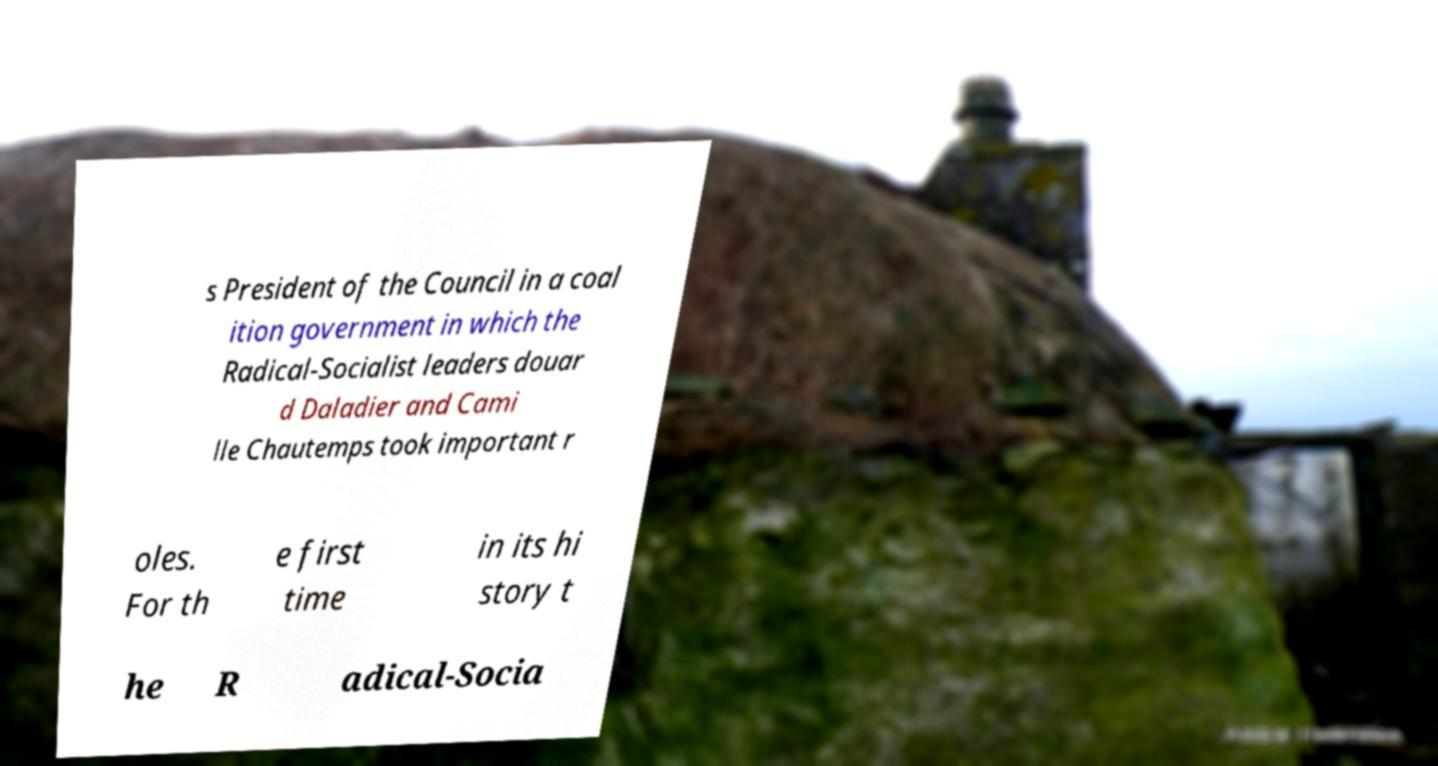For documentation purposes, I need the text within this image transcribed. Could you provide that? s President of the Council in a coal ition government in which the Radical-Socialist leaders douar d Daladier and Cami lle Chautemps took important r oles. For th e first time in its hi story t he R adical-Socia 